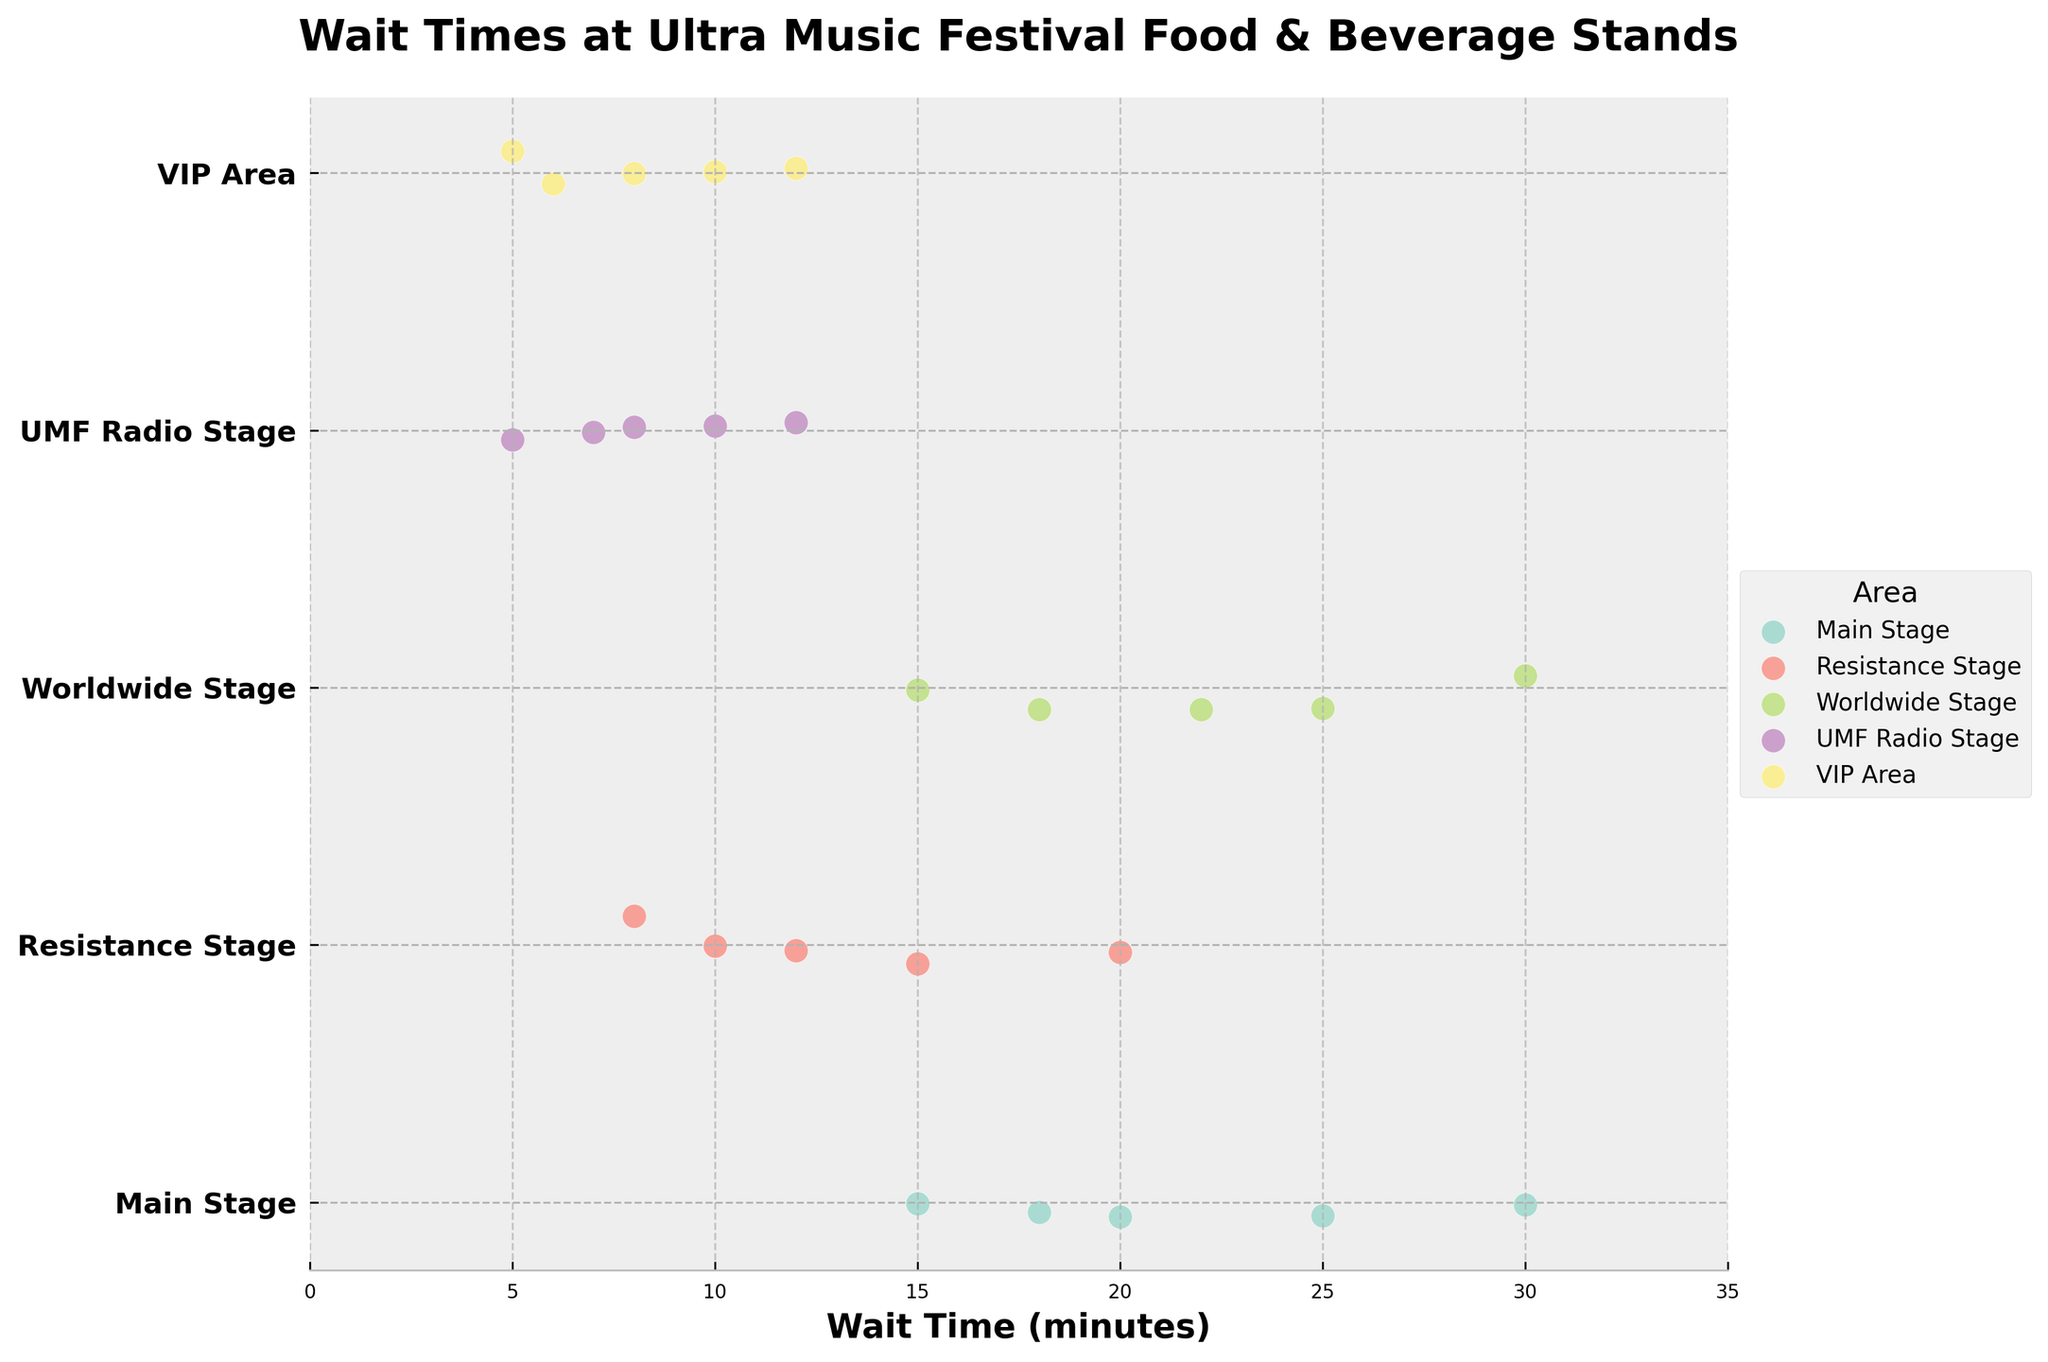What's the maximum wait time at the Main Stage? Look at the Main Stage data points on the x-axis, the maximum is the furthest point to the right.
Answer: 30 minutes What is the minimum wait time in the Resistance Stage? Identify the Resistance Stage data points, find the smallest x-axis value.
Answer: 8 minutes How many wait time observations are there in the Worldwide Stage? Count the number of data points associated with the Worldwide Stage.
Answer: 5 What area has the shortest minimum wait time? Compare the minimum wait times across all areas.
Answer: UMF Radio Stage and VIP Area (both 5 minutes) Which area has the longest maximum wait time? Compare the maximum wait times across all areas.
Answer: Main Stage and Worldwide Stage (both 30 minutes) What is the average wait time in the VIP Area? Add up the wait times in the VIP Area and divide by the count. (5 + 8 + 10 + 12 + 6) / 5 = 41 / 5
Answer: 8.2 minutes How does the variability in wait times at the UMF Radio Stage compare to the Main Stage? Compare the spread of data points between the UMF Radio Stage and Main Stage.
Answer: UMF Radio Stage has less variability Which area typically has the shortest wait time? Compare the average wait times across areas.
Answer: VIP Area Is there more variability in wait times at the Main Stage or the Resistance Stage? Examine the spread of data points (range) for both stages and compare.
Answer: Main Stage (range: 15 minutes) has more variability than Resistance Stage (range: 12 minutes to 20 minutes) What's the median wait time for the Worldwide Stage? Order the Worldwide Stage wait times, select the middle value. 15, 18, 22, 25, 30 -> the middle value is 22.
Answer: 22 minutes 